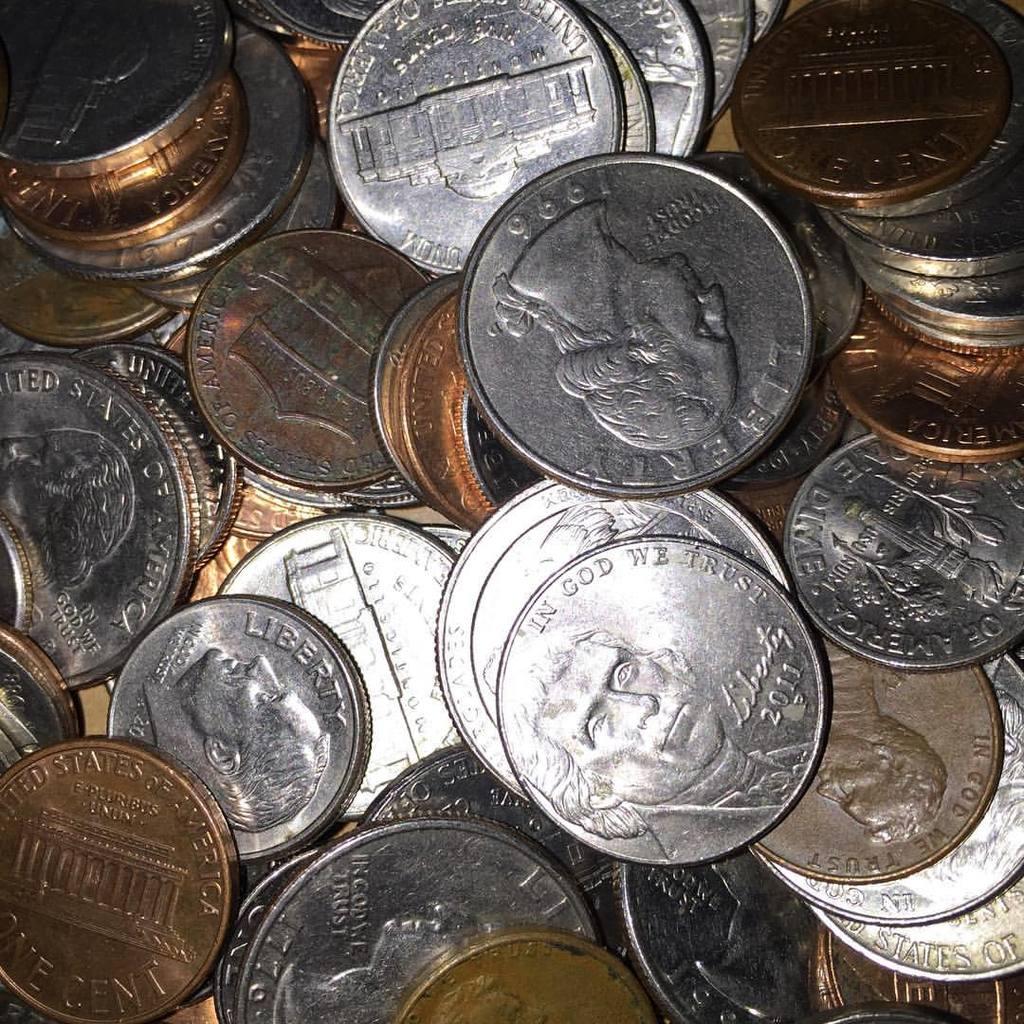What year is the middle nickel?
Keep it short and to the point. 2011. What year is on the upside down quarter?
Offer a very short reply. 1996. 